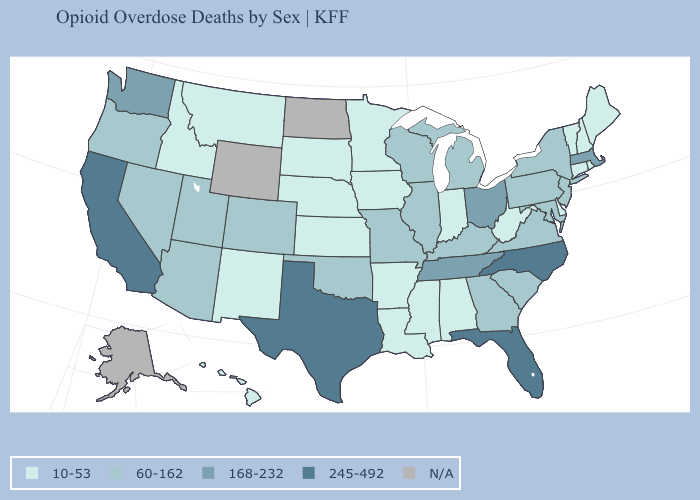What is the lowest value in the West?
Short answer required. 10-53. What is the lowest value in the West?
Short answer required. 10-53. How many symbols are there in the legend?
Give a very brief answer. 5. Name the states that have a value in the range N/A?
Give a very brief answer. Alaska, North Dakota, Wyoming. How many symbols are there in the legend?
Write a very short answer. 5. Does the map have missing data?
Answer briefly. Yes. Which states have the lowest value in the USA?
Be succinct. Alabama, Arkansas, Connecticut, Delaware, Hawaii, Idaho, Indiana, Iowa, Kansas, Louisiana, Maine, Minnesota, Mississippi, Montana, Nebraska, New Hampshire, New Mexico, Rhode Island, South Dakota, Vermont, West Virginia. Name the states that have a value in the range N/A?
Give a very brief answer. Alaska, North Dakota, Wyoming. What is the value of Oklahoma?
Answer briefly. 60-162. What is the value of Montana?
Answer briefly. 10-53. What is the value of Connecticut?
Short answer required. 10-53. What is the value of Tennessee?
Concise answer only. 168-232. Name the states that have a value in the range N/A?
Be succinct. Alaska, North Dakota, Wyoming. Does the map have missing data?
Keep it brief. Yes. Name the states that have a value in the range 168-232?
Give a very brief answer. Massachusetts, Ohio, Tennessee, Washington. 